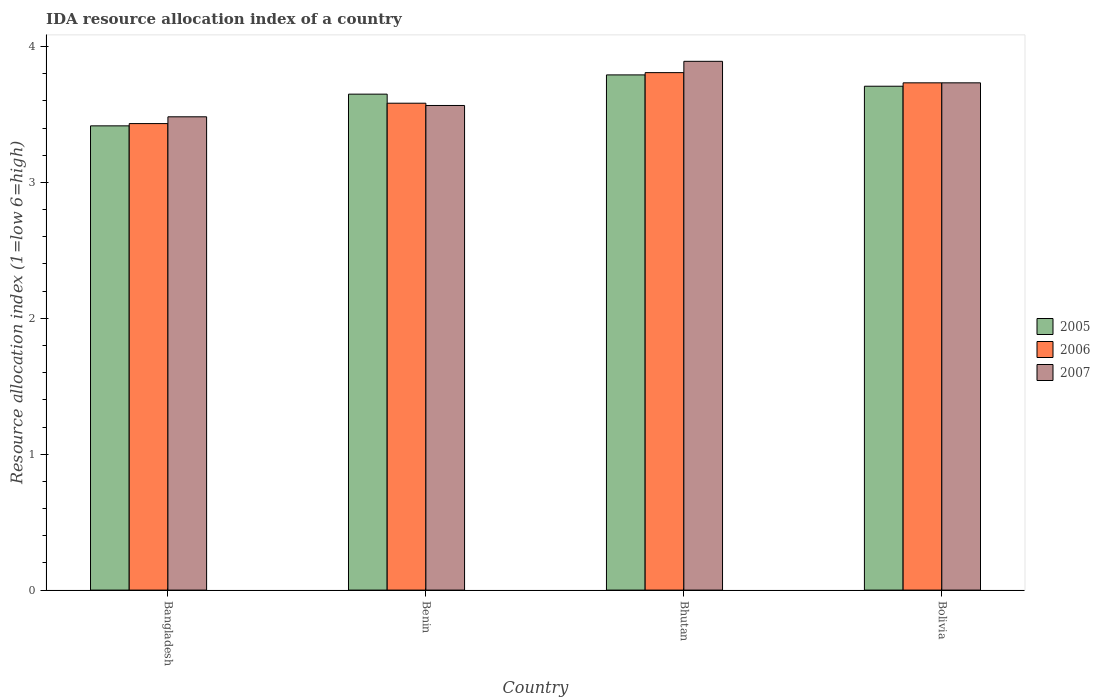How many groups of bars are there?
Provide a short and direct response. 4. Are the number of bars on each tick of the X-axis equal?
Make the answer very short. Yes. What is the label of the 3rd group of bars from the left?
Your answer should be very brief. Bhutan. In how many cases, is the number of bars for a given country not equal to the number of legend labels?
Your response must be concise. 0. What is the IDA resource allocation index in 2005 in Benin?
Offer a very short reply. 3.65. Across all countries, what is the maximum IDA resource allocation index in 2005?
Your answer should be very brief. 3.79. Across all countries, what is the minimum IDA resource allocation index in 2007?
Offer a very short reply. 3.48. In which country was the IDA resource allocation index in 2006 maximum?
Your response must be concise. Bhutan. What is the total IDA resource allocation index in 2006 in the graph?
Your answer should be very brief. 14.56. What is the difference between the IDA resource allocation index in 2007 in Bangladesh and that in Bolivia?
Give a very brief answer. -0.25. What is the difference between the IDA resource allocation index in 2005 in Benin and the IDA resource allocation index in 2006 in Bhutan?
Your answer should be very brief. -0.16. What is the average IDA resource allocation index in 2007 per country?
Provide a succinct answer. 3.67. What is the difference between the IDA resource allocation index of/in 2005 and IDA resource allocation index of/in 2006 in Bolivia?
Ensure brevity in your answer.  -0.02. In how many countries, is the IDA resource allocation index in 2007 greater than 2.8?
Your response must be concise. 4. What is the ratio of the IDA resource allocation index in 2007 in Bhutan to that in Bolivia?
Your answer should be compact. 1.04. Is the IDA resource allocation index in 2007 in Bangladesh less than that in Bhutan?
Ensure brevity in your answer.  Yes. Is the difference between the IDA resource allocation index in 2005 in Bhutan and Bolivia greater than the difference between the IDA resource allocation index in 2006 in Bhutan and Bolivia?
Offer a very short reply. Yes. What is the difference between the highest and the second highest IDA resource allocation index in 2007?
Make the answer very short. 0.17. What is the difference between the highest and the lowest IDA resource allocation index in 2006?
Provide a succinct answer. 0.38. Is the sum of the IDA resource allocation index in 2006 in Bangladesh and Benin greater than the maximum IDA resource allocation index in 2005 across all countries?
Make the answer very short. Yes. What does the 1st bar from the left in Bhutan represents?
Ensure brevity in your answer.  2005. Is it the case that in every country, the sum of the IDA resource allocation index in 2007 and IDA resource allocation index in 2006 is greater than the IDA resource allocation index in 2005?
Offer a terse response. Yes. How many countries are there in the graph?
Make the answer very short. 4. What is the difference between two consecutive major ticks on the Y-axis?
Keep it short and to the point. 1. Does the graph contain any zero values?
Your answer should be very brief. No. Does the graph contain grids?
Offer a very short reply. No. Where does the legend appear in the graph?
Offer a terse response. Center right. How many legend labels are there?
Make the answer very short. 3. How are the legend labels stacked?
Provide a short and direct response. Vertical. What is the title of the graph?
Provide a short and direct response. IDA resource allocation index of a country. Does "1979" appear as one of the legend labels in the graph?
Your answer should be very brief. No. What is the label or title of the X-axis?
Keep it short and to the point. Country. What is the label or title of the Y-axis?
Offer a terse response. Resource allocation index (1=low 6=high). What is the Resource allocation index (1=low 6=high) of 2005 in Bangladesh?
Make the answer very short. 3.42. What is the Resource allocation index (1=low 6=high) of 2006 in Bangladesh?
Offer a very short reply. 3.43. What is the Resource allocation index (1=low 6=high) of 2007 in Bangladesh?
Provide a short and direct response. 3.48. What is the Resource allocation index (1=low 6=high) of 2005 in Benin?
Your response must be concise. 3.65. What is the Resource allocation index (1=low 6=high) of 2006 in Benin?
Provide a succinct answer. 3.58. What is the Resource allocation index (1=low 6=high) in 2007 in Benin?
Offer a terse response. 3.57. What is the Resource allocation index (1=low 6=high) in 2005 in Bhutan?
Offer a terse response. 3.79. What is the Resource allocation index (1=low 6=high) in 2006 in Bhutan?
Your answer should be very brief. 3.81. What is the Resource allocation index (1=low 6=high) of 2007 in Bhutan?
Ensure brevity in your answer.  3.89. What is the Resource allocation index (1=low 6=high) in 2005 in Bolivia?
Provide a succinct answer. 3.71. What is the Resource allocation index (1=low 6=high) in 2006 in Bolivia?
Ensure brevity in your answer.  3.73. What is the Resource allocation index (1=low 6=high) of 2007 in Bolivia?
Provide a short and direct response. 3.73. Across all countries, what is the maximum Resource allocation index (1=low 6=high) of 2005?
Provide a short and direct response. 3.79. Across all countries, what is the maximum Resource allocation index (1=low 6=high) of 2006?
Offer a terse response. 3.81. Across all countries, what is the maximum Resource allocation index (1=low 6=high) in 2007?
Your answer should be compact. 3.89. Across all countries, what is the minimum Resource allocation index (1=low 6=high) of 2005?
Offer a very short reply. 3.42. Across all countries, what is the minimum Resource allocation index (1=low 6=high) in 2006?
Provide a short and direct response. 3.43. Across all countries, what is the minimum Resource allocation index (1=low 6=high) of 2007?
Your answer should be very brief. 3.48. What is the total Resource allocation index (1=low 6=high) of 2005 in the graph?
Your answer should be compact. 14.57. What is the total Resource allocation index (1=low 6=high) in 2006 in the graph?
Provide a succinct answer. 14.56. What is the total Resource allocation index (1=low 6=high) in 2007 in the graph?
Make the answer very short. 14.68. What is the difference between the Resource allocation index (1=low 6=high) in 2005 in Bangladesh and that in Benin?
Provide a succinct answer. -0.23. What is the difference between the Resource allocation index (1=low 6=high) of 2006 in Bangladesh and that in Benin?
Make the answer very short. -0.15. What is the difference between the Resource allocation index (1=low 6=high) in 2007 in Bangladesh and that in Benin?
Your answer should be very brief. -0.08. What is the difference between the Resource allocation index (1=low 6=high) in 2005 in Bangladesh and that in Bhutan?
Ensure brevity in your answer.  -0.38. What is the difference between the Resource allocation index (1=low 6=high) in 2006 in Bangladesh and that in Bhutan?
Provide a succinct answer. -0.38. What is the difference between the Resource allocation index (1=low 6=high) of 2007 in Bangladesh and that in Bhutan?
Your answer should be very brief. -0.41. What is the difference between the Resource allocation index (1=low 6=high) in 2005 in Bangladesh and that in Bolivia?
Make the answer very short. -0.29. What is the difference between the Resource allocation index (1=low 6=high) in 2006 in Bangladesh and that in Bolivia?
Provide a succinct answer. -0.3. What is the difference between the Resource allocation index (1=low 6=high) in 2005 in Benin and that in Bhutan?
Provide a succinct answer. -0.14. What is the difference between the Resource allocation index (1=low 6=high) of 2006 in Benin and that in Bhutan?
Make the answer very short. -0.23. What is the difference between the Resource allocation index (1=low 6=high) of 2007 in Benin and that in Bhutan?
Your answer should be compact. -0.33. What is the difference between the Resource allocation index (1=low 6=high) of 2005 in Benin and that in Bolivia?
Your response must be concise. -0.06. What is the difference between the Resource allocation index (1=low 6=high) in 2005 in Bhutan and that in Bolivia?
Offer a terse response. 0.08. What is the difference between the Resource allocation index (1=low 6=high) of 2006 in Bhutan and that in Bolivia?
Provide a succinct answer. 0.07. What is the difference between the Resource allocation index (1=low 6=high) of 2007 in Bhutan and that in Bolivia?
Ensure brevity in your answer.  0.16. What is the difference between the Resource allocation index (1=low 6=high) of 2006 in Bangladesh and the Resource allocation index (1=low 6=high) of 2007 in Benin?
Your answer should be compact. -0.13. What is the difference between the Resource allocation index (1=low 6=high) of 2005 in Bangladesh and the Resource allocation index (1=low 6=high) of 2006 in Bhutan?
Ensure brevity in your answer.  -0.39. What is the difference between the Resource allocation index (1=low 6=high) of 2005 in Bangladesh and the Resource allocation index (1=low 6=high) of 2007 in Bhutan?
Keep it short and to the point. -0.47. What is the difference between the Resource allocation index (1=low 6=high) in 2006 in Bangladesh and the Resource allocation index (1=low 6=high) in 2007 in Bhutan?
Offer a terse response. -0.46. What is the difference between the Resource allocation index (1=low 6=high) of 2005 in Bangladesh and the Resource allocation index (1=low 6=high) of 2006 in Bolivia?
Your answer should be compact. -0.32. What is the difference between the Resource allocation index (1=low 6=high) of 2005 in Bangladesh and the Resource allocation index (1=low 6=high) of 2007 in Bolivia?
Your response must be concise. -0.32. What is the difference between the Resource allocation index (1=low 6=high) in 2006 in Bangladesh and the Resource allocation index (1=low 6=high) in 2007 in Bolivia?
Your response must be concise. -0.3. What is the difference between the Resource allocation index (1=low 6=high) of 2005 in Benin and the Resource allocation index (1=low 6=high) of 2006 in Bhutan?
Provide a succinct answer. -0.16. What is the difference between the Resource allocation index (1=low 6=high) in 2005 in Benin and the Resource allocation index (1=low 6=high) in 2007 in Bhutan?
Offer a terse response. -0.24. What is the difference between the Resource allocation index (1=low 6=high) of 2006 in Benin and the Resource allocation index (1=low 6=high) of 2007 in Bhutan?
Offer a terse response. -0.31. What is the difference between the Resource allocation index (1=low 6=high) of 2005 in Benin and the Resource allocation index (1=low 6=high) of 2006 in Bolivia?
Offer a very short reply. -0.08. What is the difference between the Resource allocation index (1=low 6=high) of 2005 in Benin and the Resource allocation index (1=low 6=high) of 2007 in Bolivia?
Offer a terse response. -0.08. What is the difference between the Resource allocation index (1=low 6=high) of 2006 in Benin and the Resource allocation index (1=low 6=high) of 2007 in Bolivia?
Make the answer very short. -0.15. What is the difference between the Resource allocation index (1=low 6=high) of 2005 in Bhutan and the Resource allocation index (1=low 6=high) of 2006 in Bolivia?
Your answer should be very brief. 0.06. What is the difference between the Resource allocation index (1=low 6=high) in 2005 in Bhutan and the Resource allocation index (1=low 6=high) in 2007 in Bolivia?
Your answer should be very brief. 0.06. What is the difference between the Resource allocation index (1=low 6=high) of 2006 in Bhutan and the Resource allocation index (1=low 6=high) of 2007 in Bolivia?
Provide a succinct answer. 0.07. What is the average Resource allocation index (1=low 6=high) of 2005 per country?
Provide a short and direct response. 3.64. What is the average Resource allocation index (1=low 6=high) of 2006 per country?
Provide a short and direct response. 3.64. What is the average Resource allocation index (1=low 6=high) of 2007 per country?
Give a very brief answer. 3.67. What is the difference between the Resource allocation index (1=low 6=high) of 2005 and Resource allocation index (1=low 6=high) of 2006 in Bangladesh?
Provide a succinct answer. -0.02. What is the difference between the Resource allocation index (1=low 6=high) in 2005 and Resource allocation index (1=low 6=high) in 2007 in Bangladesh?
Offer a terse response. -0.07. What is the difference between the Resource allocation index (1=low 6=high) of 2006 and Resource allocation index (1=low 6=high) of 2007 in Bangladesh?
Provide a short and direct response. -0.05. What is the difference between the Resource allocation index (1=low 6=high) of 2005 and Resource allocation index (1=low 6=high) of 2006 in Benin?
Ensure brevity in your answer.  0.07. What is the difference between the Resource allocation index (1=low 6=high) of 2005 and Resource allocation index (1=low 6=high) of 2007 in Benin?
Provide a succinct answer. 0.08. What is the difference between the Resource allocation index (1=low 6=high) in 2006 and Resource allocation index (1=low 6=high) in 2007 in Benin?
Make the answer very short. 0.02. What is the difference between the Resource allocation index (1=low 6=high) in 2005 and Resource allocation index (1=low 6=high) in 2006 in Bhutan?
Your response must be concise. -0.02. What is the difference between the Resource allocation index (1=low 6=high) of 2005 and Resource allocation index (1=low 6=high) of 2007 in Bhutan?
Offer a very short reply. -0.1. What is the difference between the Resource allocation index (1=low 6=high) of 2006 and Resource allocation index (1=low 6=high) of 2007 in Bhutan?
Keep it short and to the point. -0.08. What is the difference between the Resource allocation index (1=low 6=high) in 2005 and Resource allocation index (1=low 6=high) in 2006 in Bolivia?
Keep it short and to the point. -0.03. What is the difference between the Resource allocation index (1=low 6=high) of 2005 and Resource allocation index (1=low 6=high) of 2007 in Bolivia?
Your answer should be very brief. -0.03. What is the ratio of the Resource allocation index (1=low 6=high) in 2005 in Bangladesh to that in Benin?
Your answer should be compact. 0.94. What is the ratio of the Resource allocation index (1=low 6=high) in 2006 in Bangladesh to that in Benin?
Your answer should be very brief. 0.96. What is the ratio of the Resource allocation index (1=low 6=high) in 2007 in Bangladesh to that in Benin?
Offer a very short reply. 0.98. What is the ratio of the Resource allocation index (1=low 6=high) in 2005 in Bangladesh to that in Bhutan?
Your answer should be compact. 0.9. What is the ratio of the Resource allocation index (1=low 6=high) in 2006 in Bangladesh to that in Bhutan?
Keep it short and to the point. 0.9. What is the ratio of the Resource allocation index (1=low 6=high) in 2007 in Bangladesh to that in Bhutan?
Offer a very short reply. 0.9. What is the ratio of the Resource allocation index (1=low 6=high) of 2005 in Bangladesh to that in Bolivia?
Your answer should be compact. 0.92. What is the ratio of the Resource allocation index (1=low 6=high) in 2006 in Bangladesh to that in Bolivia?
Provide a succinct answer. 0.92. What is the ratio of the Resource allocation index (1=low 6=high) of 2007 in Bangladesh to that in Bolivia?
Your answer should be very brief. 0.93. What is the ratio of the Resource allocation index (1=low 6=high) in 2005 in Benin to that in Bhutan?
Provide a succinct answer. 0.96. What is the ratio of the Resource allocation index (1=low 6=high) in 2006 in Benin to that in Bhutan?
Offer a very short reply. 0.94. What is the ratio of the Resource allocation index (1=low 6=high) of 2007 in Benin to that in Bhutan?
Ensure brevity in your answer.  0.92. What is the ratio of the Resource allocation index (1=low 6=high) in 2005 in Benin to that in Bolivia?
Your answer should be compact. 0.98. What is the ratio of the Resource allocation index (1=low 6=high) of 2006 in Benin to that in Bolivia?
Ensure brevity in your answer.  0.96. What is the ratio of the Resource allocation index (1=low 6=high) of 2007 in Benin to that in Bolivia?
Ensure brevity in your answer.  0.96. What is the ratio of the Resource allocation index (1=low 6=high) in 2005 in Bhutan to that in Bolivia?
Your response must be concise. 1.02. What is the ratio of the Resource allocation index (1=low 6=high) of 2006 in Bhutan to that in Bolivia?
Offer a terse response. 1.02. What is the ratio of the Resource allocation index (1=low 6=high) of 2007 in Bhutan to that in Bolivia?
Your response must be concise. 1.04. What is the difference between the highest and the second highest Resource allocation index (1=low 6=high) of 2005?
Provide a succinct answer. 0.08. What is the difference between the highest and the second highest Resource allocation index (1=low 6=high) of 2006?
Offer a very short reply. 0.07. What is the difference between the highest and the second highest Resource allocation index (1=low 6=high) in 2007?
Ensure brevity in your answer.  0.16. What is the difference between the highest and the lowest Resource allocation index (1=low 6=high) of 2005?
Provide a short and direct response. 0.38. What is the difference between the highest and the lowest Resource allocation index (1=low 6=high) in 2006?
Provide a short and direct response. 0.38. What is the difference between the highest and the lowest Resource allocation index (1=low 6=high) in 2007?
Give a very brief answer. 0.41. 